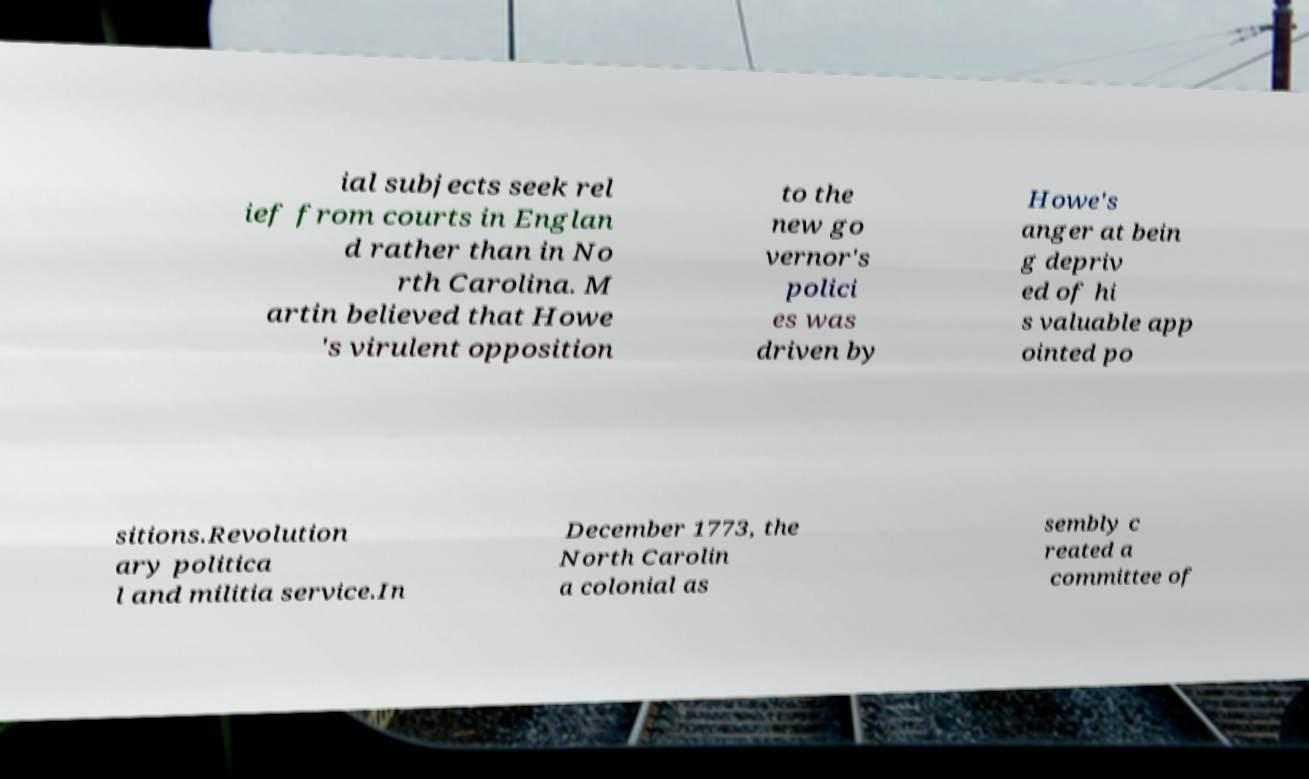Please read and relay the text visible in this image. What does it say? ial subjects seek rel ief from courts in Englan d rather than in No rth Carolina. M artin believed that Howe 's virulent opposition to the new go vernor's polici es was driven by Howe's anger at bein g depriv ed of hi s valuable app ointed po sitions.Revolution ary politica l and militia service.In December 1773, the North Carolin a colonial as sembly c reated a committee of 